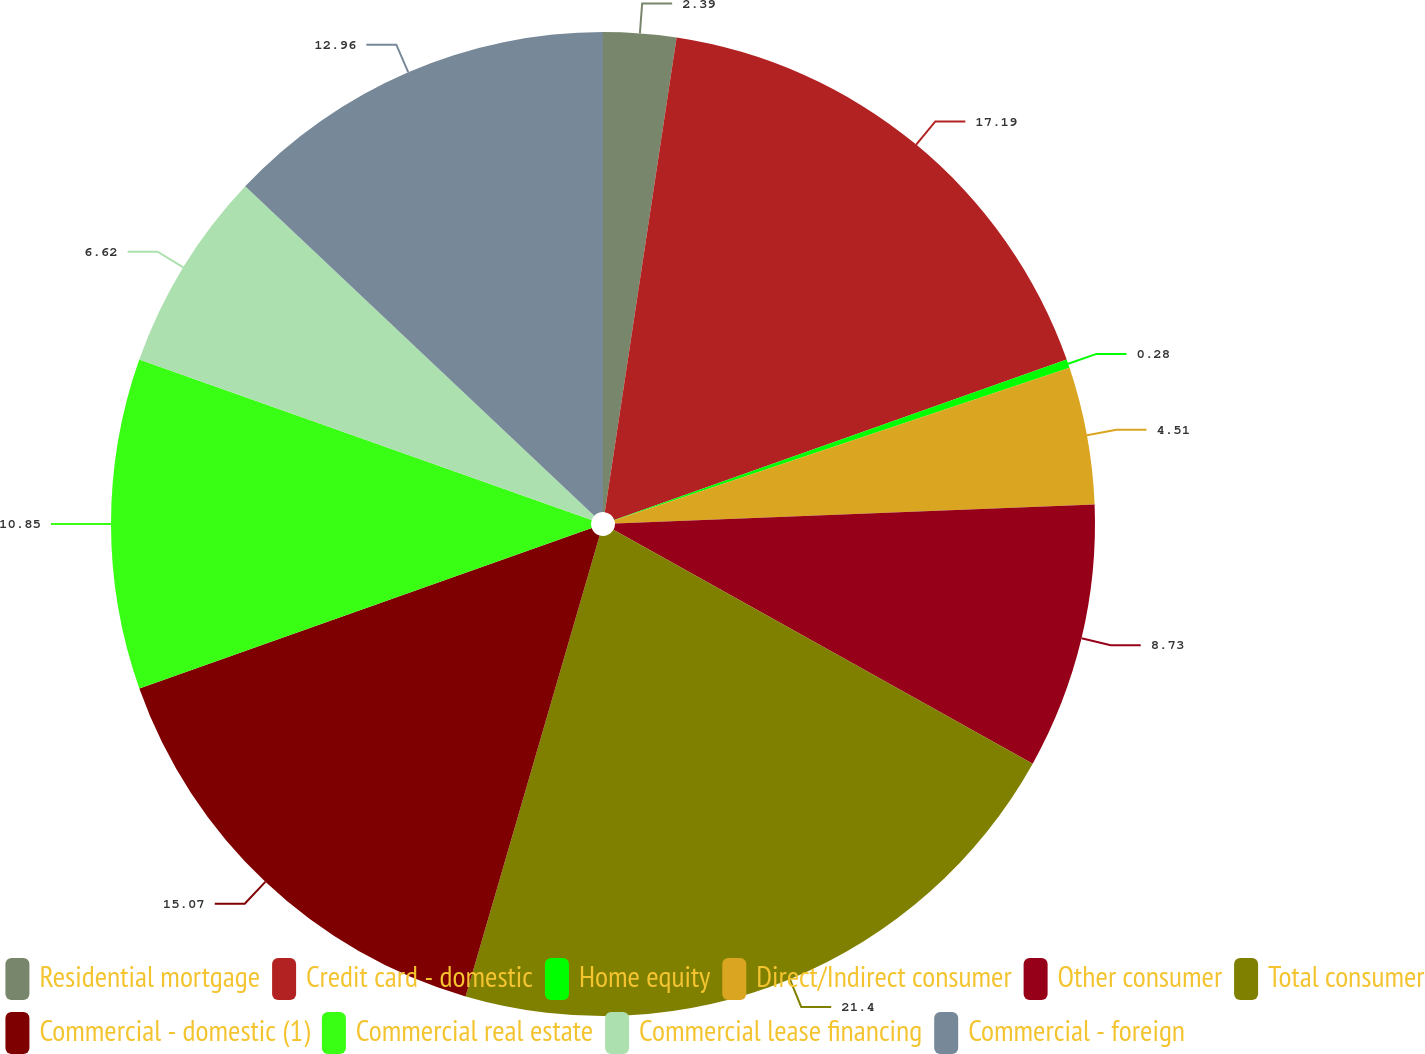Convert chart. <chart><loc_0><loc_0><loc_500><loc_500><pie_chart><fcel>Residential mortgage<fcel>Credit card - domestic<fcel>Home equity<fcel>Direct/Indirect consumer<fcel>Other consumer<fcel>Total consumer<fcel>Commercial - domestic (1)<fcel>Commercial real estate<fcel>Commercial lease financing<fcel>Commercial - foreign<nl><fcel>2.39%<fcel>17.19%<fcel>0.28%<fcel>4.51%<fcel>8.73%<fcel>21.41%<fcel>15.07%<fcel>10.85%<fcel>6.62%<fcel>12.96%<nl></chart> 